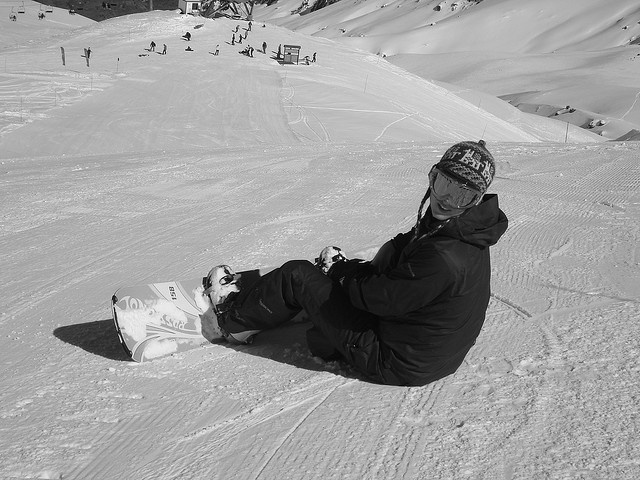Describe the objects in this image and their specific colors. I can see people in darkgray, black, gray, and lightgray tones, snowboard in darkgray, lightgray, gray, and black tones, people in darkgray, lightgray, gray, and black tones, people in darkgray, black, gray, and lightgray tones, and people in darkgray, black, gray, and lightgray tones in this image. 